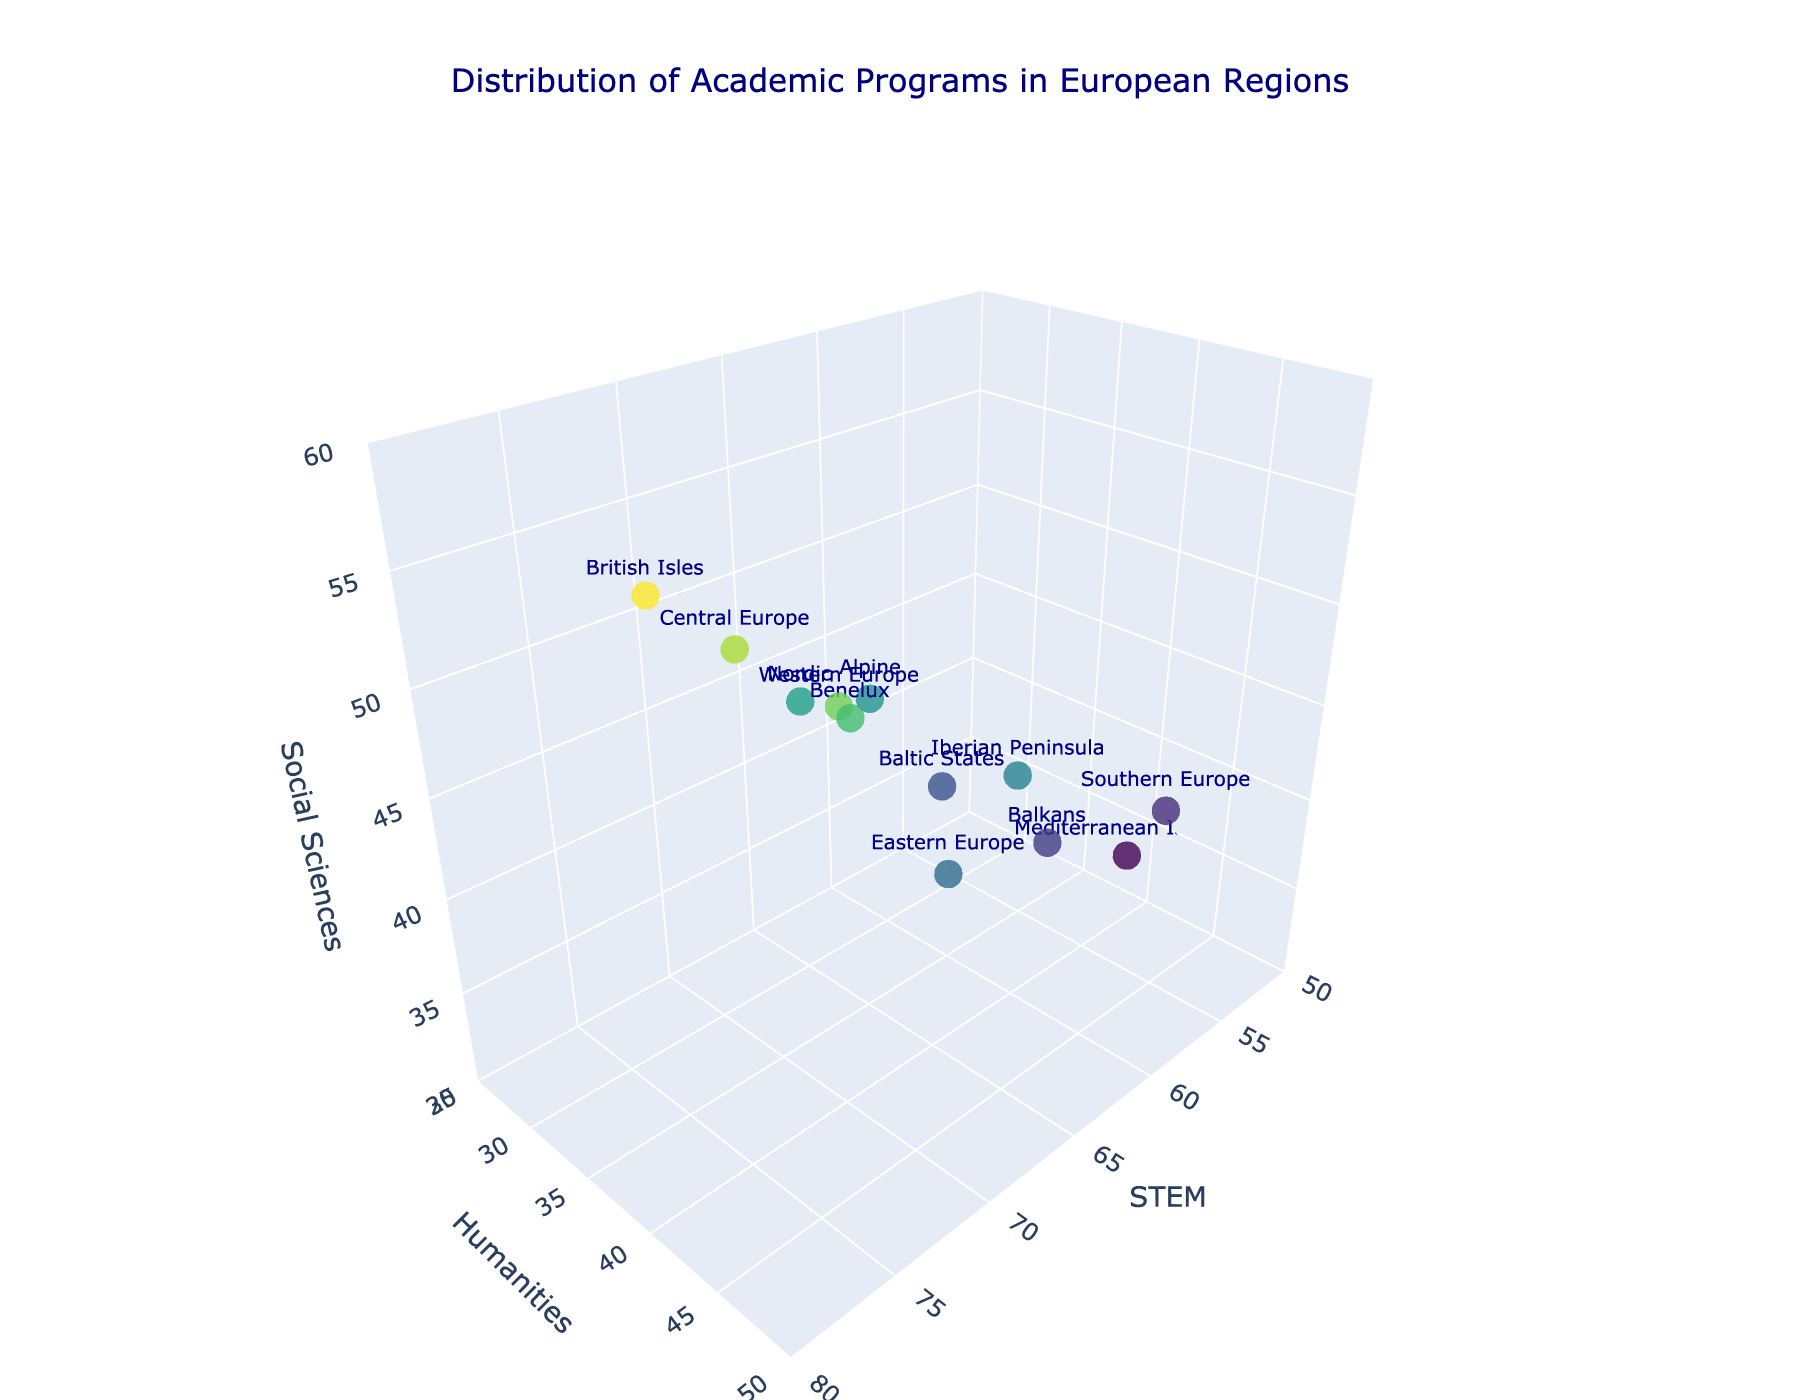What is the title of the 3D scatter plot? The title of the 3D scatter plot is clearly indicated at the top of the plot in large text. It provides a summary of the data being visualized.
Answer: Distribution of Academic Programs in European Regions How many data points are shown in the figure? Each region is represented by one data point on the 3D scatter plot. To find the total number of data points, count the number of regions listed on the axes.
Answer: 12 Which region offers the highest number of STEM programs? By looking at the 'x' axis (STEM) of the scatter plot, locate the data point furthest to the right. The text label next to this data point will indicate the region.
Answer: British Isles Which regions offer an equal number of Humanities programs? Examine the 'y' axis of the scatter plot to find data points that align horizontally at the same level. The corresponding text labels next to these points will identify the regions.
Answer: Nordic and Balkan What is the average number of Social Sciences programs offered by the Nordic and the Baltic States? Find the 'z' values for Nordic (45) and Baltic States (38) on the scatter plot. Add these values and divide by 2 to get the average. (45+38)/2 = 41.5
Answer: 41.5 Which region is closest to the center of the scatter plot? Determine the central point of the plot by averaging the ranges for STEM, Humanities, and Social Sciences axes. Then, identify which data point is visually nearest to this central position.
Answer: Eastern Europe Which region has the largest difference between the number of STEM and Humanities programs? Calculate the difference between the 'x' and 'y' values for each data point, i.e., STEM - Humanities. Identify the region with the largest absolute value of this difference.
Answer: British Isles Which two regions have the closest counts for Social Sciences programs? Look at the 'z' axis values and visually compare the heights of the data points. Identify two regions that have the smallest visual difference in the 'z' values.
Answer: Nordic and Iberian Peninsula If you average the number of STEM programs in Western Europe and the British Isles, what would the value be? Find the 'x' values for Western Europe (70) and British Isles (75). Add these values and divide by 2 to get the average. (70 + 75) / 2 = 72.5
Answer: 72.5 